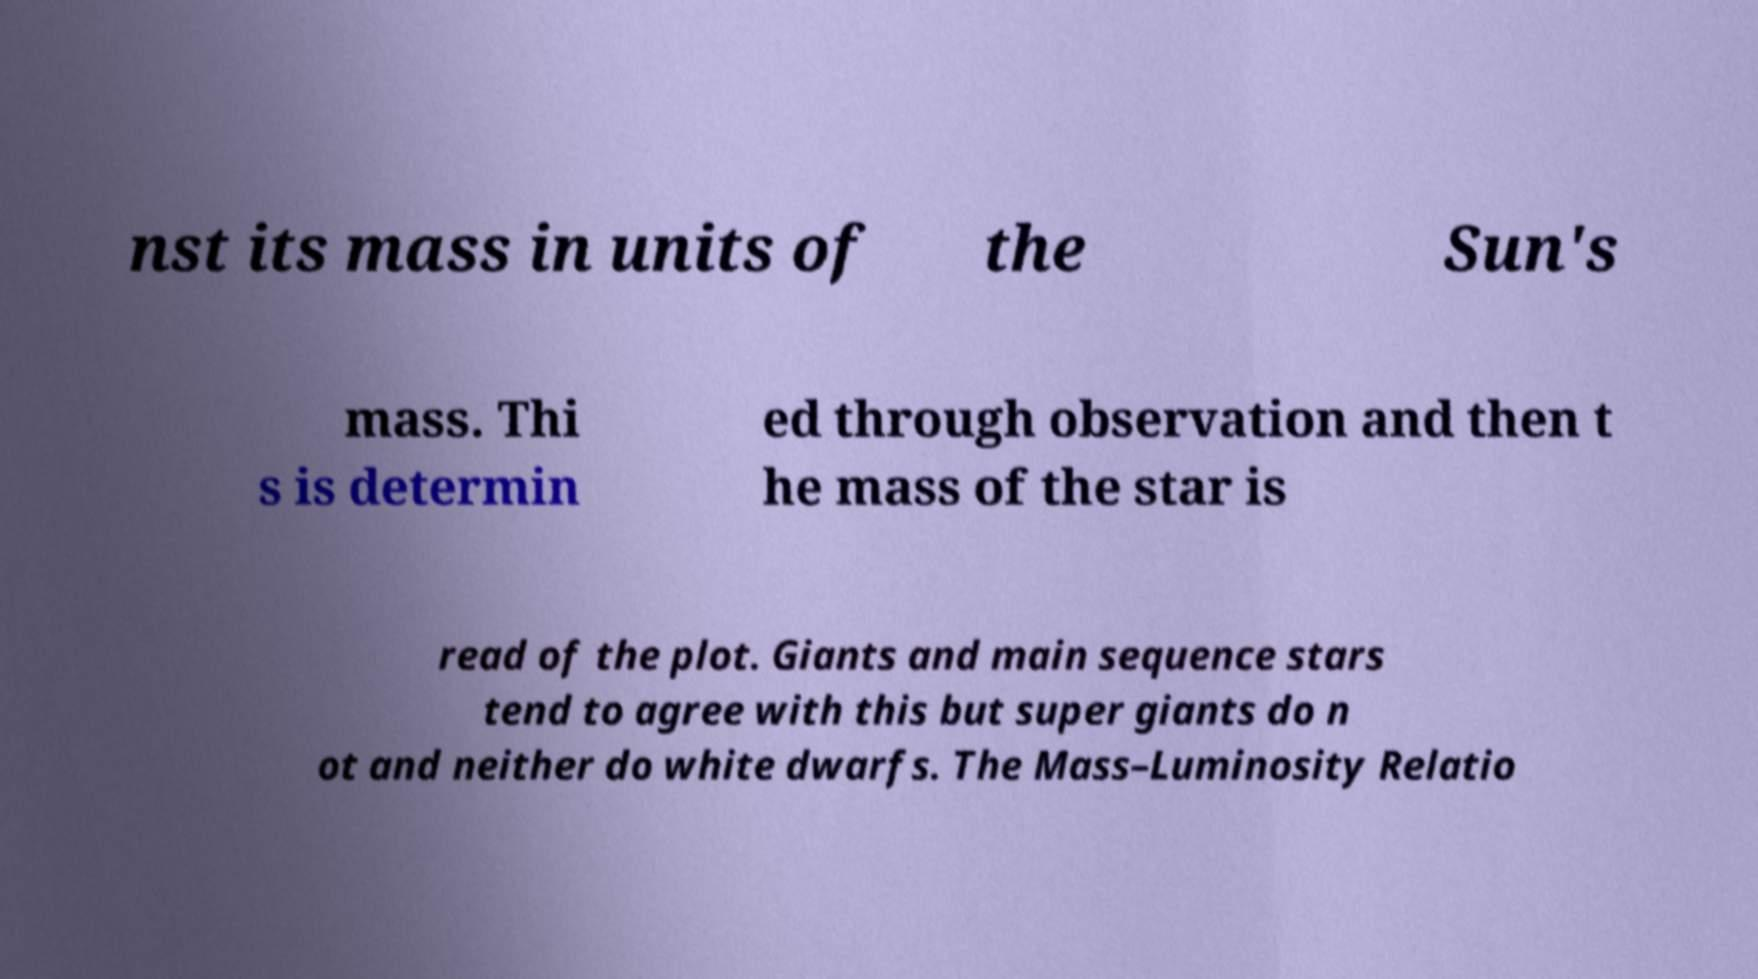Can you read and provide the text displayed in the image?This photo seems to have some interesting text. Can you extract and type it out for me? nst its mass in units of the Sun's mass. Thi s is determin ed through observation and then t he mass of the star is read of the plot. Giants and main sequence stars tend to agree with this but super giants do n ot and neither do white dwarfs. The Mass–Luminosity Relatio 